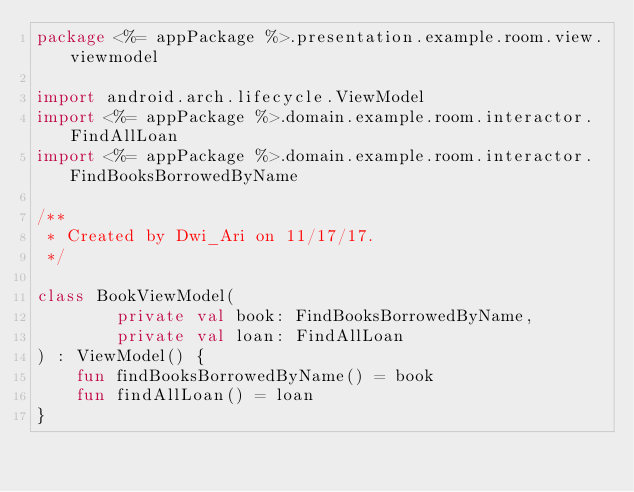<code> <loc_0><loc_0><loc_500><loc_500><_Kotlin_>package <%= appPackage %>.presentation.example.room.view.viewmodel

import android.arch.lifecycle.ViewModel
import <%= appPackage %>.domain.example.room.interactor.FindAllLoan
import <%= appPackage %>.domain.example.room.interactor.FindBooksBorrowedByName

/**
 * Created by Dwi_Ari on 11/17/17.
 */

class BookViewModel(
        private val book: FindBooksBorrowedByName,
        private val loan: FindAllLoan
) : ViewModel() {
    fun findBooksBorrowedByName() = book
    fun findAllLoan() = loan
}
</code> 